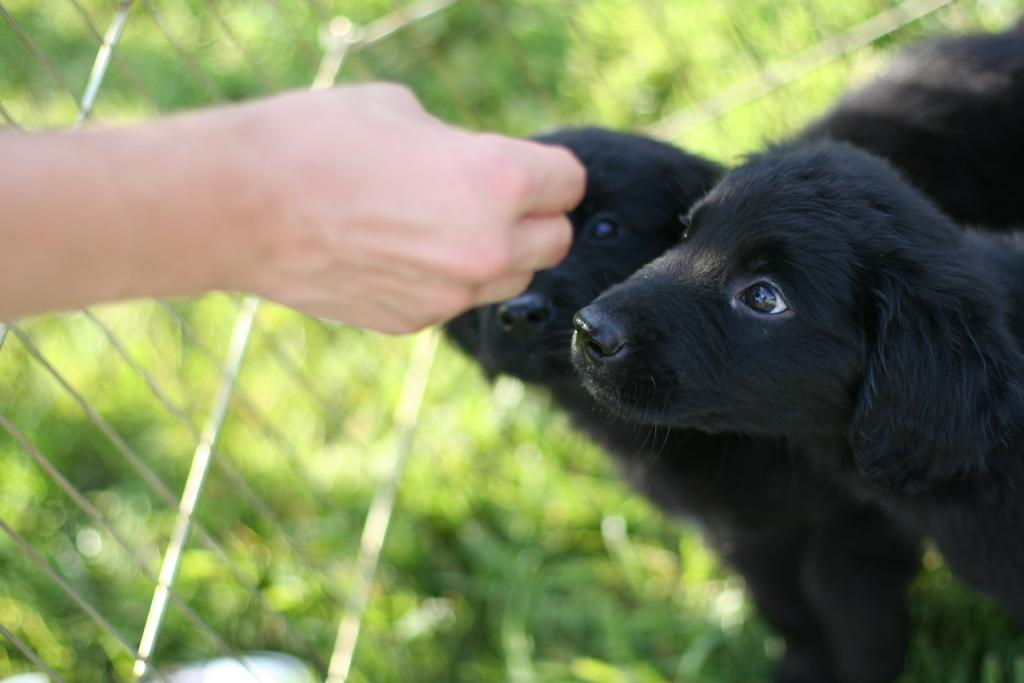What can be seen in the background of the image? There is a fence and green leaves in the background of the image. What type of animals are present in the image? There are black dogs in the image. Can you describe any human presence in the image? The hand of a person is visible on the left side of the image. What type of floor can be seen in the image? There is no floor visible in the image; it only shows black dogs, a hand, and a background with a fence and green leaves. 